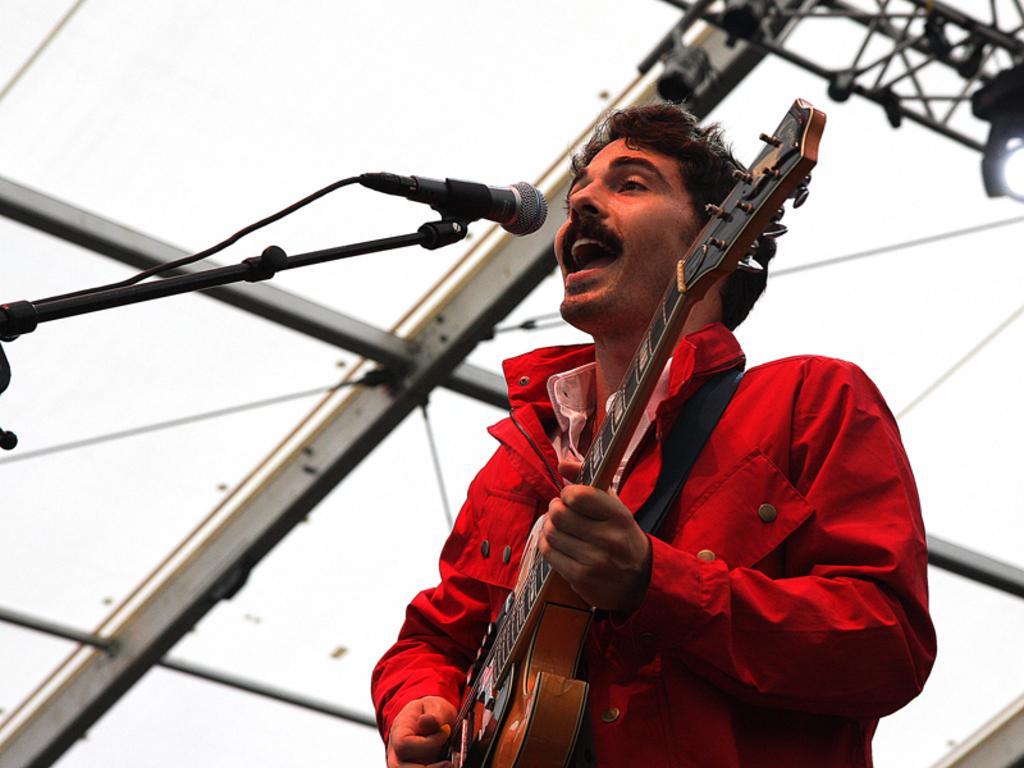Can you describe this image briefly? A person is playing a guitar and singing in-front of mic. Background we can see rods and focusing lights.  